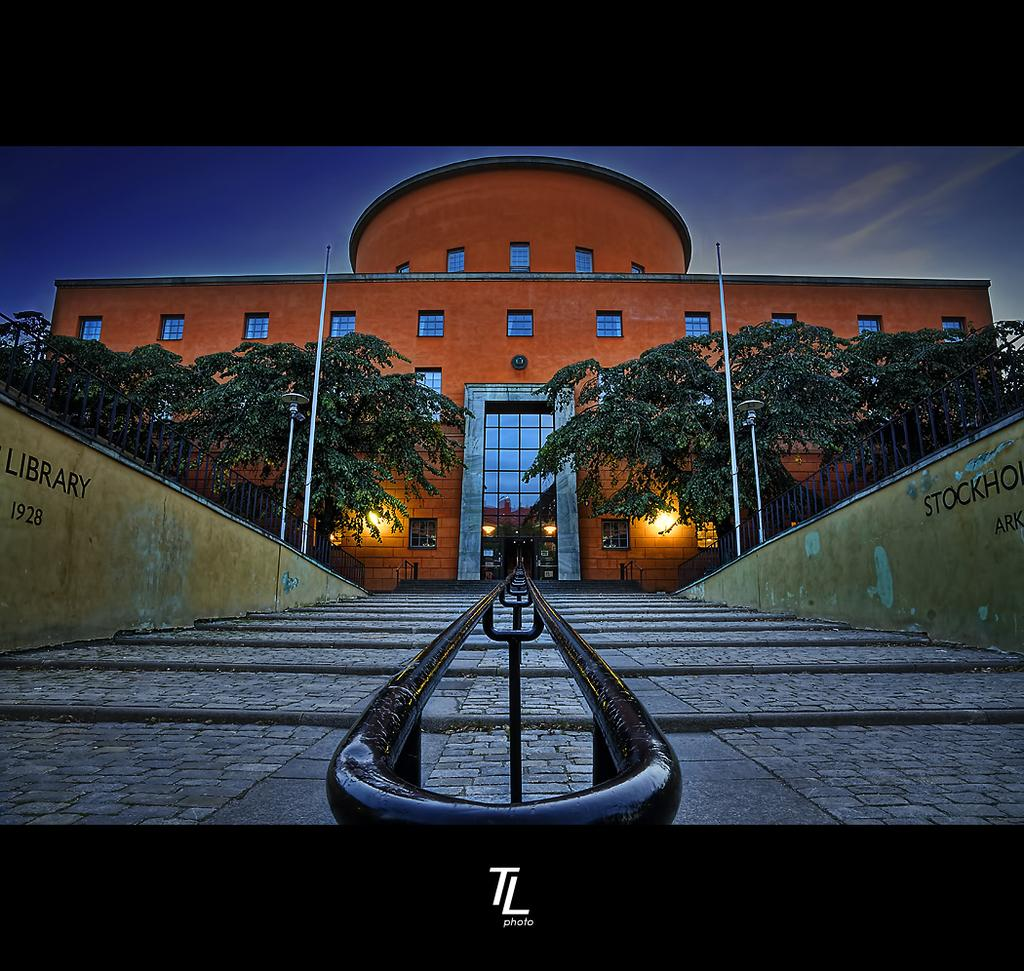What type of building is in the picture? There is a library building in the picture. How would you describe the size of the library building? The library building is described as huge. Are there any trees visible in the image? Yes, there are two trees in front of the library building. What is the entrance to the library building like? There are stairs in front of the door of the library. What type of skin condition can be seen on the trees in the image? There is no mention of any skin condition on the trees in the image. The trees are simply described as being in front of the library building. 